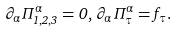<formula> <loc_0><loc_0><loc_500><loc_500>\partial _ { \alpha } \Pi ^ { \alpha } _ { 1 , 2 , 3 } = 0 , \, \partial _ { \alpha } \Pi ^ { \alpha } _ { \tau } = f _ { \tau } .</formula> 